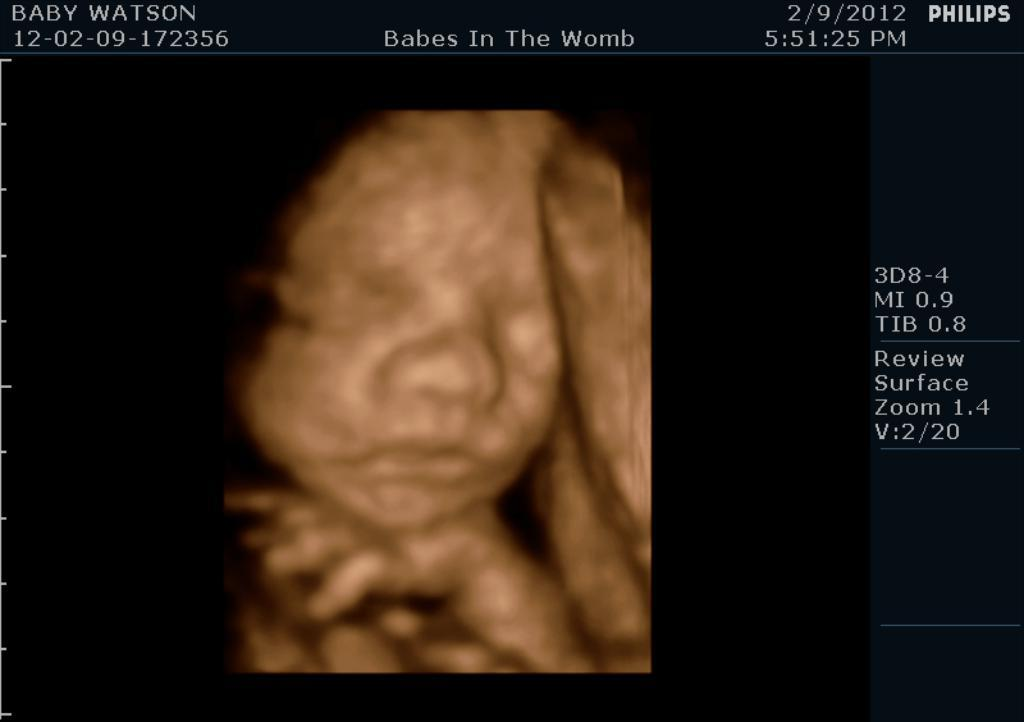What is the main object in the image? There is a screen in the image. What can be seen on the screen? A baby is visible on the screen. Are there any words or letters on the screen? Yes, there is text on the screen. How many dogs are visible on the screen? There are no dogs visible on the screen; it features a baby and text. Is there a bee buzzing around the baby on the screen? There is no bee present on the screen; it only shows a baby and text. 